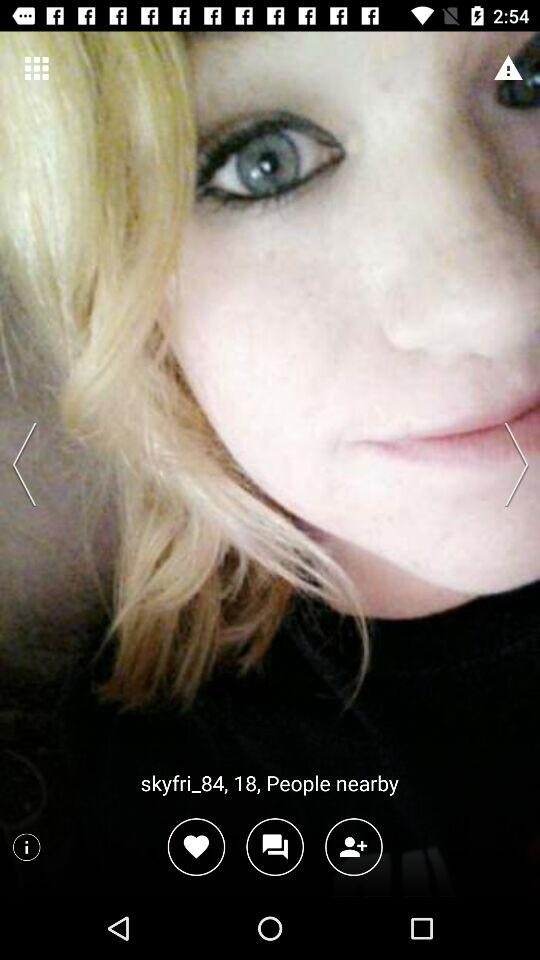What's the total number of people nearby?
When the provided information is insufficient, respond with <no answer>. <no answer> 